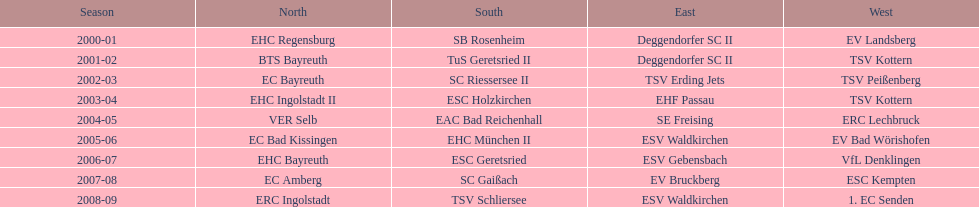The last team to win the west? 1. EC Senden. 